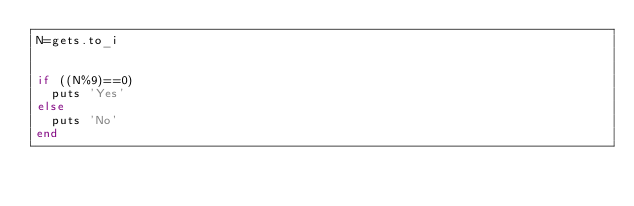<code> <loc_0><loc_0><loc_500><loc_500><_Ruby_>N=gets.to_i


if ((N%9)==0)
  puts 'Yes'
else
  puts 'No'
end</code> 